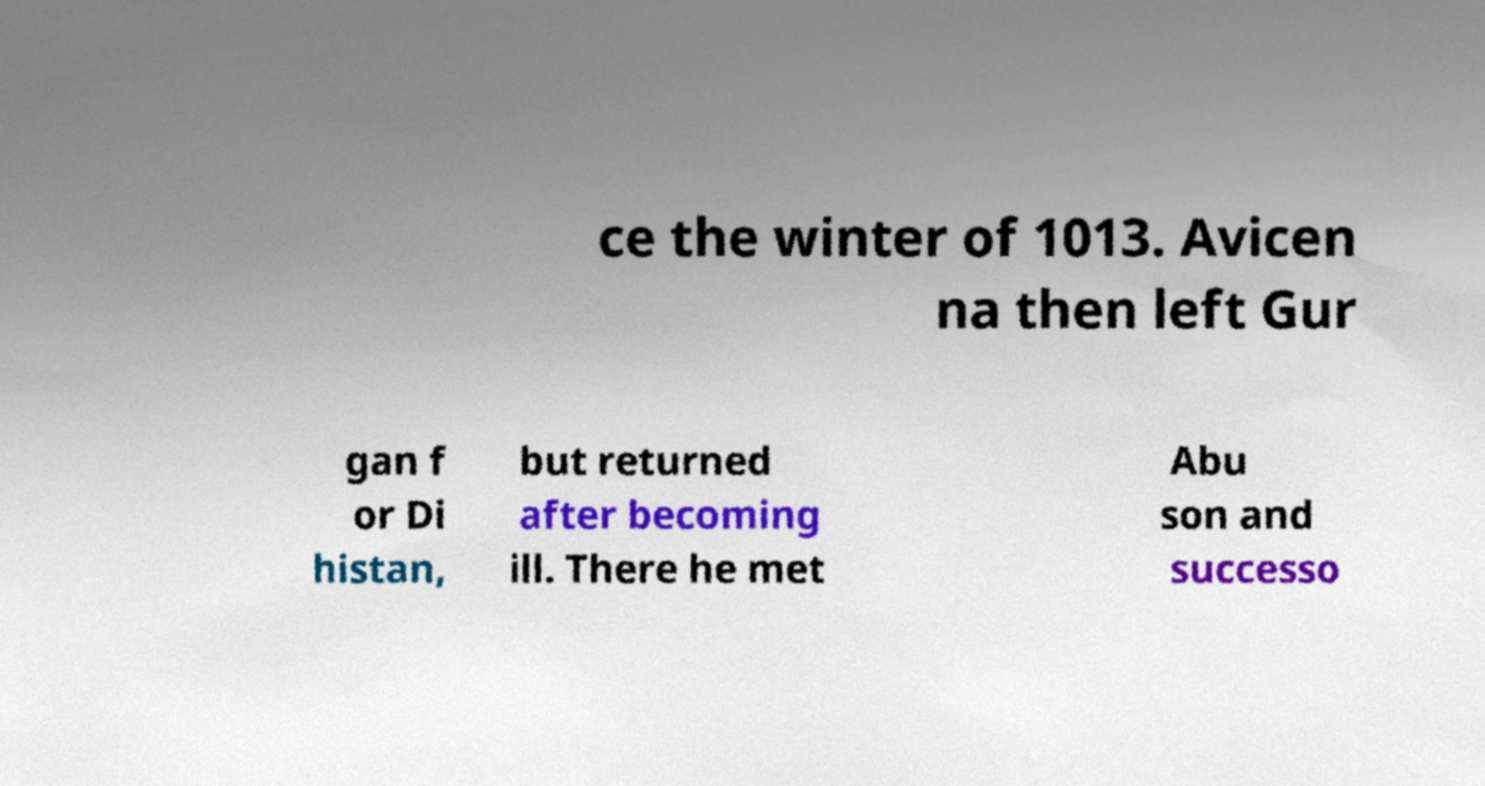Please identify and transcribe the text found in this image. ce the winter of 1013. Avicen na then left Gur gan f or Di histan, but returned after becoming ill. There he met Abu son and successo 